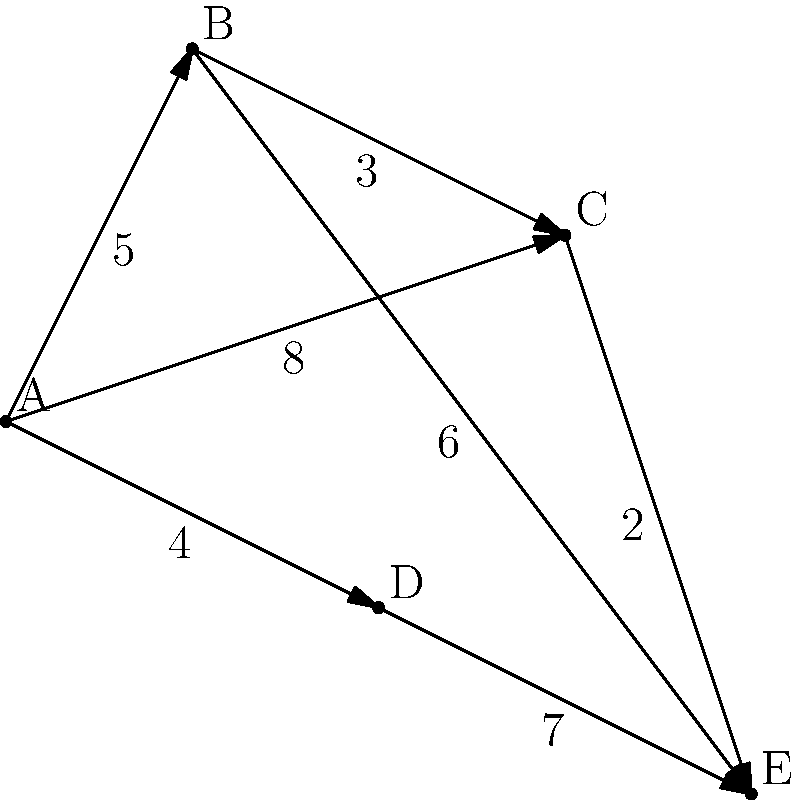Given the network diagram representing a freight transportation system, where nodes represent cities and edge weights represent transportation costs in millions of dollars, what is the optimal route from city A to city E that minimizes total cost? List the cities in order and provide the total cost. To find the optimal route from city A to city E, we need to consider all possible paths and their total costs. Let's analyze the options step-by-step:

1. Path A-B-E:
   Cost = $5 + $6 = $11 million

2. Path A-B-C-E:
   Cost = $5 + $3 + $2 = $10 million

3. Path A-C-E:
   Cost = $8 + $2 = $10 million

4. Path A-D-E:
   Cost = $4 + $7 = $11 million

5. Path A-C-B-E:
   Cost = $8 + $3 + $6 = $17 million (not optimal, can be disregarded)

Comparing the total costs:
- A-B-E: $11 million
- A-B-C-E: $10 million
- A-C-E: $10 million
- A-D-E: $11 million

The optimal routes with the minimum cost are A-B-C-E and A-C-E, both costing $10 million. However, A-C-E is shorter in terms of the number of cities visited, making it the most efficient choice.
Answer: A-C-E, $10 million 